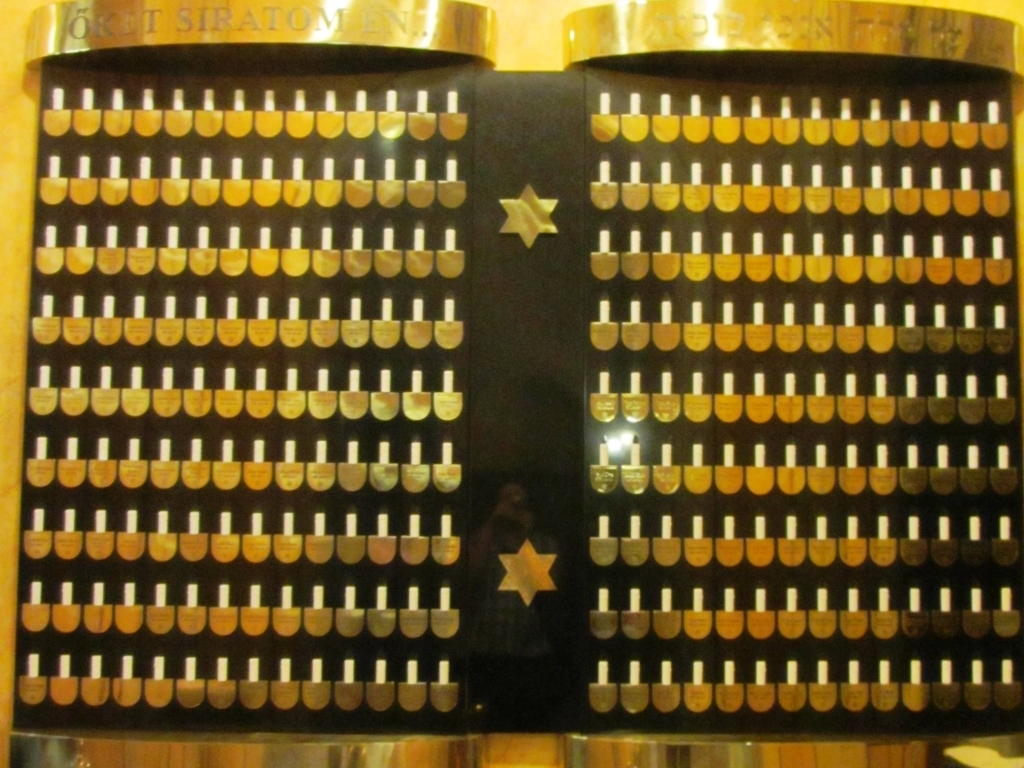What time period do you think this object is from? Based on the design and mechanical complexity, it likely dates back to the late 19th or early 20th century, a time when mechanical calculators were widely used in business and scientific fields. 